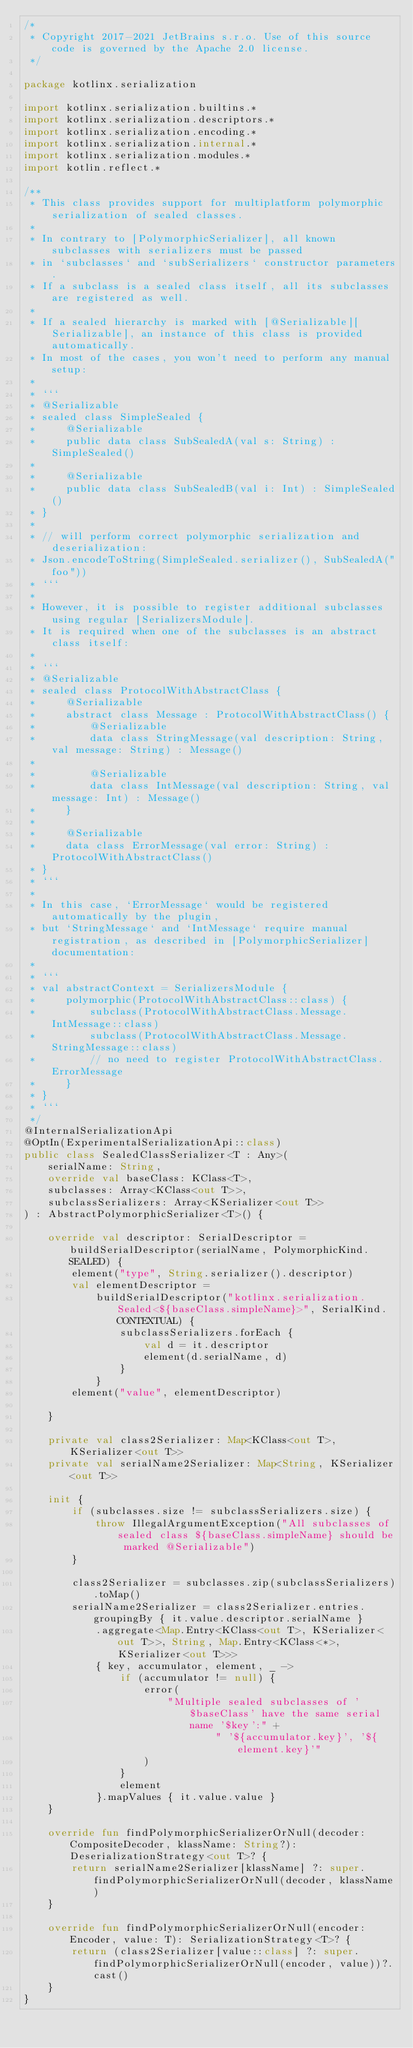<code> <loc_0><loc_0><loc_500><loc_500><_Kotlin_>/*
 * Copyright 2017-2021 JetBrains s.r.o. Use of this source code is governed by the Apache 2.0 license.
 */

package kotlinx.serialization

import kotlinx.serialization.builtins.*
import kotlinx.serialization.descriptors.*
import kotlinx.serialization.encoding.*
import kotlinx.serialization.internal.*
import kotlinx.serialization.modules.*
import kotlin.reflect.*

/**
 * This class provides support for multiplatform polymorphic serialization of sealed classes.
 *
 * In contrary to [PolymorphicSerializer], all known subclasses with serializers must be passed
 * in `subclasses` and `subSerializers` constructor parameters.
 * If a subclass is a sealed class itself, all its subclasses are registered as well.
 *
 * If a sealed hierarchy is marked with [@Serializable][Serializable], an instance of this class is provided automatically.
 * In most of the cases, you won't need to perform any manual setup:
 *
 * ```
 * @Serializable
 * sealed class SimpleSealed {
 *     @Serializable
 *     public data class SubSealedA(val s: String) : SimpleSealed()
 *
 *     @Serializable
 *     public data class SubSealedB(val i: Int) : SimpleSealed()
 * }
 *
 * // will perform correct polymorphic serialization and deserialization:
 * Json.encodeToString(SimpleSealed.serializer(), SubSealedA("foo"))
 * ```
 *
 * However, it is possible to register additional subclasses using regular [SerializersModule].
 * It is required when one of the subclasses is an abstract class itself:
 *
 * ```
 * @Serializable
 * sealed class ProtocolWithAbstractClass {
 *     @Serializable
 *     abstract class Message : ProtocolWithAbstractClass() {
 *         @Serializable
 *         data class StringMessage(val description: String, val message: String) : Message()
 *
 *         @Serializable
 *         data class IntMessage(val description: String, val message: Int) : Message()
 *     }
 *
 *     @Serializable
 *     data class ErrorMessage(val error: String) : ProtocolWithAbstractClass()
 * }
 * ```
 *
 * In this case, `ErrorMessage` would be registered automatically by the plugin,
 * but `StringMessage` and `IntMessage` require manual registration, as described in [PolymorphicSerializer] documentation:
 *
 * ```
 * val abstractContext = SerializersModule {
 *     polymorphic(ProtocolWithAbstractClass::class) {
 *         subclass(ProtocolWithAbstractClass.Message.IntMessage::class)
 *         subclass(ProtocolWithAbstractClass.Message.StringMessage::class)
 *         // no need to register ProtocolWithAbstractClass.ErrorMessage
 *     }
 * }
 * ```
 */
@InternalSerializationApi
@OptIn(ExperimentalSerializationApi::class)
public class SealedClassSerializer<T : Any>(
    serialName: String,
    override val baseClass: KClass<T>,
    subclasses: Array<KClass<out T>>,
    subclassSerializers: Array<KSerializer<out T>>
) : AbstractPolymorphicSerializer<T>() {

    override val descriptor: SerialDescriptor = buildSerialDescriptor(serialName, PolymorphicKind.SEALED) {
        element("type", String.serializer().descriptor)
        val elementDescriptor =
            buildSerialDescriptor("kotlinx.serialization.Sealed<${baseClass.simpleName}>", SerialKind.CONTEXTUAL) {
                subclassSerializers.forEach {
                    val d = it.descriptor
                    element(d.serialName, d)
                }
            }
        element("value", elementDescriptor)

    }

    private val class2Serializer: Map<KClass<out T>, KSerializer<out T>>
    private val serialName2Serializer: Map<String, KSerializer<out T>>

    init {
        if (subclasses.size != subclassSerializers.size) {
            throw IllegalArgumentException("All subclasses of sealed class ${baseClass.simpleName} should be marked @Serializable")
        }

        class2Serializer = subclasses.zip(subclassSerializers).toMap()
        serialName2Serializer = class2Serializer.entries.groupingBy { it.value.descriptor.serialName }
            .aggregate<Map.Entry<KClass<out T>, KSerializer<out T>>, String, Map.Entry<KClass<*>, KSerializer<out T>>>
            { key, accumulator, element, _ ->
                if (accumulator != null) {
                    error(
                        "Multiple sealed subclasses of '$baseClass' have the same serial name '$key':" +
                                " '${accumulator.key}', '${element.key}'"
                    )
                }
                element
            }.mapValues { it.value.value }
    }

    override fun findPolymorphicSerializerOrNull(decoder: CompositeDecoder, klassName: String?): DeserializationStrategy<out T>? {
        return serialName2Serializer[klassName] ?: super.findPolymorphicSerializerOrNull(decoder, klassName)
    }

    override fun findPolymorphicSerializerOrNull(encoder: Encoder, value: T): SerializationStrategy<T>? {
        return (class2Serializer[value::class] ?: super.findPolymorphicSerializerOrNull(encoder, value))?.cast()
    }
}
</code> 